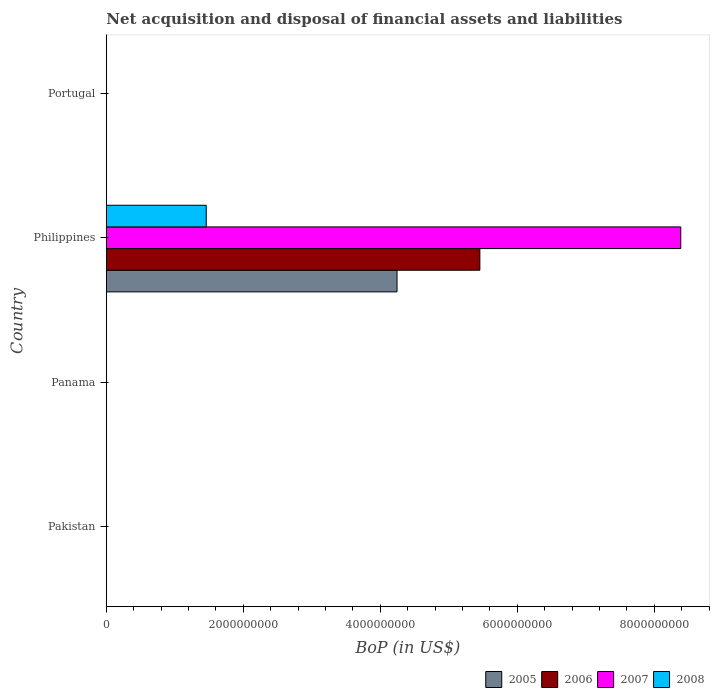How many different coloured bars are there?
Offer a terse response. 4. Are the number of bars per tick equal to the number of legend labels?
Your answer should be very brief. No. How many bars are there on the 3rd tick from the top?
Provide a succinct answer. 0. What is the label of the 2nd group of bars from the top?
Ensure brevity in your answer.  Philippines. In how many cases, is the number of bars for a given country not equal to the number of legend labels?
Your answer should be very brief. 3. What is the Balance of Payments in 2006 in Philippines?
Offer a terse response. 5.45e+09. Across all countries, what is the maximum Balance of Payments in 2008?
Provide a short and direct response. 1.46e+09. Across all countries, what is the minimum Balance of Payments in 2006?
Provide a succinct answer. 0. In which country was the Balance of Payments in 2008 maximum?
Ensure brevity in your answer.  Philippines. What is the total Balance of Payments in 2006 in the graph?
Offer a very short reply. 5.45e+09. What is the difference between the Balance of Payments in 2008 in Panama and the Balance of Payments in 2005 in Philippines?
Keep it short and to the point. -4.24e+09. What is the average Balance of Payments in 2006 per country?
Provide a succinct answer. 1.36e+09. What is the difference between the Balance of Payments in 2005 and Balance of Payments in 2007 in Philippines?
Your answer should be very brief. -4.14e+09. In how many countries, is the Balance of Payments in 2007 greater than 7600000000 US$?
Keep it short and to the point. 1. What is the difference between the highest and the lowest Balance of Payments in 2008?
Your answer should be compact. 1.46e+09. Is it the case that in every country, the sum of the Balance of Payments in 2005 and Balance of Payments in 2007 is greater than the sum of Balance of Payments in 2008 and Balance of Payments in 2006?
Your answer should be very brief. No. How many countries are there in the graph?
Keep it short and to the point. 4. Where does the legend appear in the graph?
Ensure brevity in your answer.  Bottom right. What is the title of the graph?
Your answer should be compact. Net acquisition and disposal of financial assets and liabilities. What is the label or title of the X-axis?
Your answer should be compact. BoP (in US$). What is the label or title of the Y-axis?
Your response must be concise. Country. What is the BoP (in US$) in 2006 in Pakistan?
Your answer should be very brief. 0. What is the BoP (in US$) of 2007 in Pakistan?
Your answer should be compact. 0. What is the BoP (in US$) of 2008 in Pakistan?
Ensure brevity in your answer.  0. What is the BoP (in US$) of 2005 in Philippines?
Make the answer very short. 4.24e+09. What is the BoP (in US$) in 2006 in Philippines?
Your answer should be very brief. 5.45e+09. What is the BoP (in US$) of 2007 in Philippines?
Your answer should be very brief. 8.39e+09. What is the BoP (in US$) in 2008 in Philippines?
Provide a succinct answer. 1.46e+09. What is the BoP (in US$) in 2008 in Portugal?
Make the answer very short. 0. Across all countries, what is the maximum BoP (in US$) in 2005?
Offer a very short reply. 4.24e+09. Across all countries, what is the maximum BoP (in US$) of 2006?
Provide a succinct answer. 5.45e+09. Across all countries, what is the maximum BoP (in US$) of 2007?
Offer a terse response. 8.39e+09. Across all countries, what is the maximum BoP (in US$) in 2008?
Give a very brief answer. 1.46e+09. Across all countries, what is the minimum BoP (in US$) of 2006?
Your response must be concise. 0. What is the total BoP (in US$) of 2005 in the graph?
Provide a succinct answer. 4.24e+09. What is the total BoP (in US$) in 2006 in the graph?
Your answer should be very brief. 5.45e+09. What is the total BoP (in US$) in 2007 in the graph?
Your answer should be compact. 8.39e+09. What is the total BoP (in US$) of 2008 in the graph?
Your answer should be very brief. 1.46e+09. What is the average BoP (in US$) of 2005 per country?
Offer a terse response. 1.06e+09. What is the average BoP (in US$) of 2006 per country?
Your response must be concise. 1.36e+09. What is the average BoP (in US$) in 2007 per country?
Provide a short and direct response. 2.10e+09. What is the average BoP (in US$) in 2008 per country?
Give a very brief answer. 3.65e+08. What is the difference between the BoP (in US$) in 2005 and BoP (in US$) in 2006 in Philippines?
Give a very brief answer. -1.21e+09. What is the difference between the BoP (in US$) in 2005 and BoP (in US$) in 2007 in Philippines?
Give a very brief answer. -4.14e+09. What is the difference between the BoP (in US$) of 2005 and BoP (in US$) of 2008 in Philippines?
Your answer should be very brief. 2.79e+09. What is the difference between the BoP (in US$) in 2006 and BoP (in US$) in 2007 in Philippines?
Provide a succinct answer. -2.93e+09. What is the difference between the BoP (in US$) in 2006 and BoP (in US$) in 2008 in Philippines?
Offer a very short reply. 3.99e+09. What is the difference between the BoP (in US$) in 2007 and BoP (in US$) in 2008 in Philippines?
Your answer should be very brief. 6.93e+09. What is the difference between the highest and the lowest BoP (in US$) in 2005?
Provide a succinct answer. 4.24e+09. What is the difference between the highest and the lowest BoP (in US$) of 2006?
Provide a short and direct response. 5.45e+09. What is the difference between the highest and the lowest BoP (in US$) of 2007?
Your response must be concise. 8.39e+09. What is the difference between the highest and the lowest BoP (in US$) in 2008?
Keep it short and to the point. 1.46e+09. 